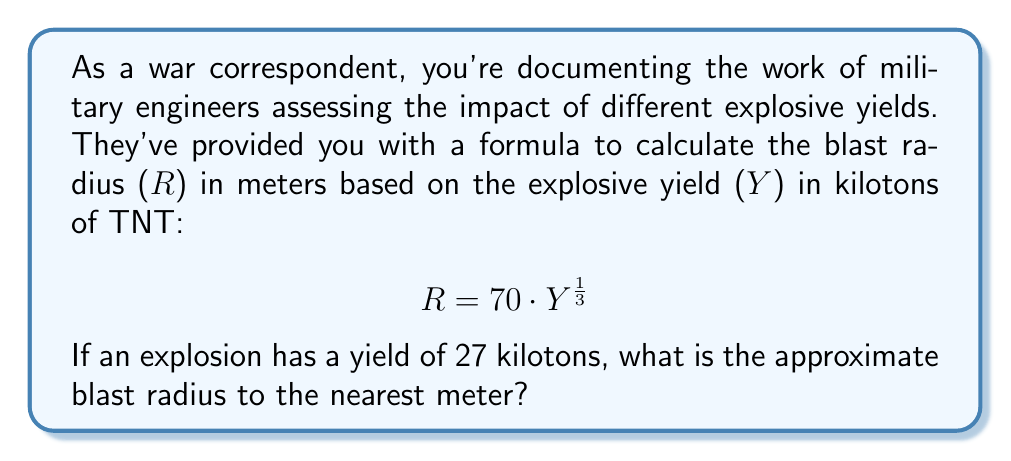What is the answer to this math problem? To solve this problem, we'll use the given formula and substitute the known value for the yield (Y).

1. Given formula: $$ R = 70 \cdot Y^{\frac{1}{3}} $$

2. Substitute Y = 27 kilotons into the formula:
   $$ R = 70 \cdot (27)^{\frac{1}{3}} $$

3. Calculate the cube root of 27:
   $$ (27)^{\frac{1}{3}} = 3 $$

4. Multiply the result by 70:
   $$ R = 70 \cdot 3 = 210 $$

5. The question asks for the answer to the nearest meter, but our result is already a whole number, so no rounding is necessary.

Therefore, the blast radius for an explosion with a yield of 27 kilotons is approximately 210 meters.
Answer: 210 meters 